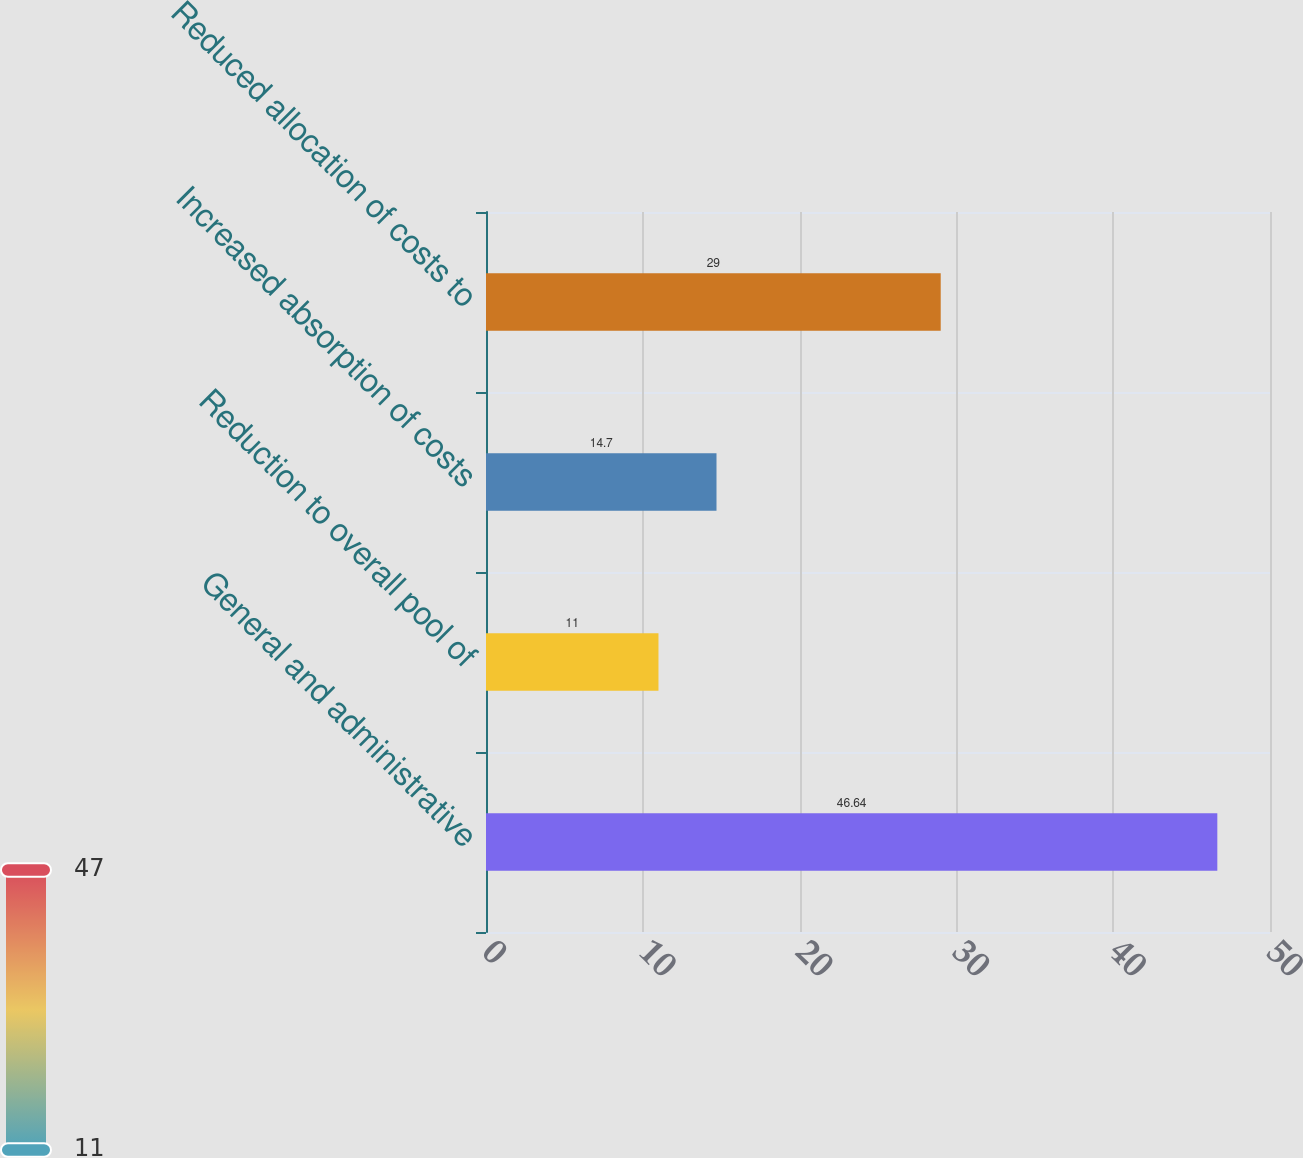Convert chart to OTSL. <chart><loc_0><loc_0><loc_500><loc_500><bar_chart><fcel>General and administrative<fcel>Reduction to overall pool of<fcel>Increased absorption of costs<fcel>Reduced allocation of costs to<nl><fcel>46.64<fcel>11<fcel>14.7<fcel>29<nl></chart> 